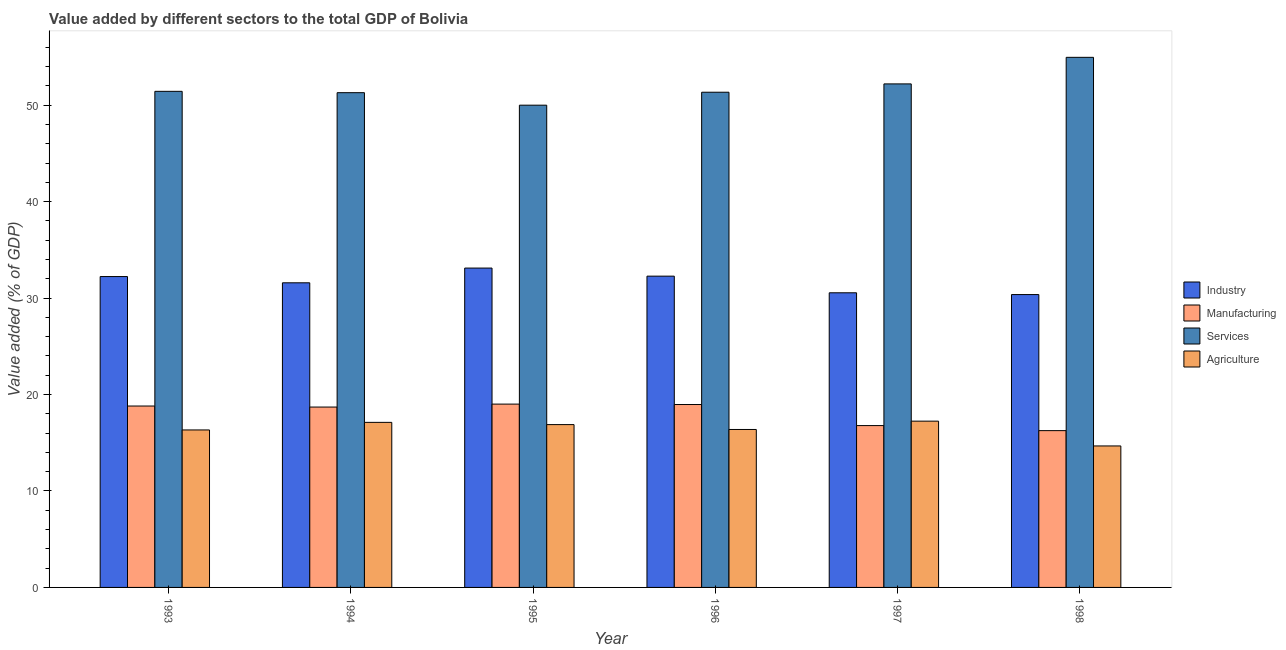How many different coloured bars are there?
Your response must be concise. 4. How many groups of bars are there?
Provide a short and direct response. 6. Are the number of bars per tick equal to the number of legend labels?
Give a very brief answer. Yes. Are the number of bars on each tick of the X-axis equal?
Your answer should be compact. Yes. How many bars are there on the 5th tick from the left?
Offer a terse response. 4. In how many cases, is the number of bars for a given year not equal to the number of legend labels?
Your answer should be compact. 0. What is the value added by services sector in 1998?
Provide a succinct answer. 54.96. Across all years, what is the maximum value added by agricultural sector?
Offer a very short reply. 17.24. Across all years, what is the minimum value added by agricultural sector?
Give a very brief answer. 14.67. In which year was the value added by agricultural sector minimum?
Offer a terse response. 1998. What is the total value added by industrial sector in the graph?
Your answer should be compact. 190.12. What is the difference between the value added by services sector in 1995 and that in 1998?
Your response must be concise. -4.96. What is the difference between the value added by agricultural sector in 1998 and the value added by industrial sector in 1996?
Provide a succinct answer. -1.71. What is the average value added by industrial sector per year?
Give a very brief answer. 31.69. What is the ratio of the value added by services sector in 1994 to that in 1996?
Give a very brief answer. 1. Is the difference between the value added by services sector in 1995 and 1996 greater than the difference between the value added by manufacturing sector in 1995 and 1996?
Make the answer very short. No. What is the difference between the highest and the second highest value added by industrial sector?
Provide a short and direct response. 0.84. What is the difference between the highest and the lowest value added by industrial sector?
Your response must be concise. 2.75. Is it the case that in every year, the sum of the value added by manufacturing sector and value added by services sector is greater than the sum of value added by industrial sector and value added by agricultural sector?
Your response must be concise. No. What does the 2nd bar from the left in 1993 represents?
Ensure brevity in your answer.  Manufacturing. What does the 1st bar from the right in 1998 represents?
Keep it short and to the point. Agriculture. How many bars are there?
Make the answer very short. 24. Are the values on the major ticks of Y-axis written in scientific E-notation?
Your answer should be compact. No. Does the graph contain any zero values?
Make the answer very short. No. Does the graph contain grids?
Your response must be concise. No. How are the legend labels stacked?
Your response must be concise. Vertical. What is the title of the graph?
Keep it short and to the point. Value added by different sectors to the total GDP of Bolivia. What is the label or title of the X-axis?
Make the answer very short. Year. What is the label or title of the Y-axis?
Keep it short and to the point. Value added (% of GDP). What is the Value added (% of GDP) of Industry in 1993?
Ensure brevity in your answer.  32.23. What is the Value added (% of GDP) in Manufacturing in 1993?
Offer a very short reply. 18.81. What is the Value added (% of GDP) of Services in 1993?
Give a very brief answer. 51.44. What is the Value added (% of GDP) of Agriculture in 1993?
Offer a terse response. 16.33. What is the Value added (% of GDP) in Industry in 1994?
Your answer should be compact. 31.59. What is the Value added (% of GDP) of Manufacturing in 1994?
Offer a terse response. 18.7. What is the Value added (% of GDP) of Services in 1994?
Keep it short and to the point. 51.3. What is the Value added (% of GDP) of Agriculture in 1994?
Your answer should be compact. 17.11. What is the Value added (% of GDP) of Industry in 1995?
Provide a short and direct response. 33.11. What is the Value added (% of GDP) in Manufacturing in 1995?
Provide a succinct answer. 19.01. What is the Value added (% of GDP) in Services in 1995?
Your answer should be very brief. 50. What is the Value added (% of GDP) in Agriculture in 1995?
Offer a very short reply. 16.88. What is the Value added (% of GDP) of Industry in 1996?
Give a very brief answer. 32.28. What is the Value added (% of GDP) of Manufacturing in 1996?
Your response must be concise. 18.96. What is the Value added (% of GDP) in Services in 1996?
Provide a succinct answer. 51.35. What is the Value added (% of GDP) in Agriculture in 1996?
Your response must be concise. 16.38. What is the Value added (% of GDP) in Industry in 1997?
Offer a terse response. 30.55. What is the Value added (% of GDP) in Manufacturing in 1997?
Provide a succinct answer. 16.78. What is the Value added (% of GDP) in Services in 1997?
Provide a succinct answer. 52.21. What is the Value added (% of GDP) of Agriculture in 1997?
Your answer should be very brief. 17.24. What is the Value added (% of GDP) in Industry in 1998?
Your response must be concise. 30.37. What is the Value added (% of GDP) in Manufacturing in 1998?
Your answer should be compact. 16.26. What is the Value added (% of GDP) in Services in 1998?
Ensure brevity in your answer.  54.96. What is the Value added (% of GDP) of Agriculture in 1998?
Provide a succinct answer. 14.67. Across all years, what is the maximum Value added (% of GDP) in Industry?
Keep it short and to the point. 33.11. Across all years, what is the maximum Value added (% of GDP) in Manufacturing?
Provide a short and direct response. 19.01. Across all years, what is the maximum Value added (% of GDP) in Services?
Provide a succinct answer. 54.96. Across all years, what is the maximum Value added (% of GDP) in Agriculture?
Keep it short and to the point. 17.24. Across all years, what is the minimum Value added (% of GDP) in Industry?
Ensure brevity in your answer.  30.37. Across all years, what is the minimum Value added (% of GDP) in Manufacturing?
Keep it short and to the point. 16.26. Across all years, what is the minimum Value added (% of GDP) in Services?
Make the answer very short. 50. Across all years, what is the minimum Value added (% of GDP) in Agriculture?
Ensure brevity in your answer.  14.67. What is the total Value added (% of GDP) of Industry in the graph?
Give a very brief answer. 190.12. What is the total Value added (% of GDP) of Manufacturing in the graph?
Your response must be concise. 108.52. What is the total Value added (% of GDP) in Services in the graph?
Provide a succinct answer. 311.26. What is the total Value added (% of GDP) in Agriculture in the graph?
Keep it short and to the point. 98.62. What is the difference between the Value added (% of GDP) of Industry in 1993 and that in 1994?
Ensure brevity in your answer.  0.65. What is the difference between the Value added (% of GDP) of Manufacturing in 1993 and that in 1994?
Provide a succinct answer. 0.11. What is the difference between the Value added (% of GDP) of Services in 1993 and that in 1994?
Provide a short and direct response. 0.14. What is the difference between the Value added (% of GDP) of Agriculture in 1993 and that in 1994?
Your response must be concise. -0.79. What is the difference between the Value added (% of GDP) in Industry in 1993 and that in 1995?
Provide a short and direct response. -0.88. What is the difference between the Value added (% of GDP) in Manufacturing in 1993 and that in 1995?
Keep it short and to the point. -0.2. What is the difference between the Value added (% of GDP) in Services in 1993 and that in 1995?
Offer a terse response. 1.43. What is the difference between the Value added (% of GDP) in Agriculture in 1993 and that in 1995?
Your answer should be compact. -0.55. What is the difference between the Value added (% of GDP) of Industry in 1993 and that in 1996?
Provide a succinct answer. -0.04. What is the difference between the Value added (% of GDP) of Manufacturing in 1993 and that in 1996?
Offer a terse response. -0.16. What is the difference between the Value added (% of GDP) of Services in 1993 and that in 1996?
Your answer should be compact. 0.09. What is the difference between the Value added (% of GDP) in Agriculture in 1993 and that in 1996?
Offer a very short reply. -0.05. What is the difference between the Value added (% of GDP) of Industry in 1993 and that in 1997?
Keep it short and to the point. 1.68. What is the difference between the Value added (% of GDP) of Manufacturing in 1993 and that in 1997?
Your answer should be compact. 2.03. What is the difference between the Value added (% of GDP) in Services in 1993 and that in 1997?
Offer a very short reply. -0.77. What is the difference between the Value added (% of GDP) in Agriculture in 1993 and that in 1997?
Keep it short and to the point. -0.91. What is the difference between the Value added (% of GDP) in Industry in 1993 and that in 1998?
Offer a very short reply. 1.87. What is the difference between the Value added (% of GDP) of Manufacturing in 1993 and that in 1998?
Provide a short and direct response. 2.55. What is the difference between the Value added (% of GDP) in Services in 1993 and that in 1998?
Give a very brief answer. -3.53. What is the difference between the Value added (% of GDP) in Agriculture in 1993 and that in 1998?
Your answer should be compact. 1.66. What is the difference between the Value added (% of GDP) of Industry in 1994 and that in 1995?
Make the answer very short. -1.53. What is the difference between the Value added (% of GDP) in Manufacturing in 1994 and that in 1995?
Give a very brief answer. -0.31. What is the difference between the Value added (% of GDP) of Services in 1994 and that in 1995?
Offer a terse response. 1.3. What is the difference between the Value added (% of GDP) in Agriculture in 1994 and that in 1995?
Offer a terse response. 0.23. What is the difference between the Value added (% of GDP) of Industry in 1994 and that in 1996?
Keep it short and to the point. -0.69. What is the difference between the Value added (% of GDP) in Manufacturing in 1994 and that in 1996?
Offer a very short reply. -0.26. What is the difference between the Value added (% of GDP) of Services in 1994 and that in 1996?
Offer a terse response. -0.05. What is the difference between the Value added (% of GDP) of Agriculture in 1994 and that in 1996?
Give a very brief answer. 0.74. What is the difference between the Value added (% of GDP) of Industry in 1994 and that in 1997?
Offer a terse response. 1.04. What is the difference between the Value added (% of GDP) of Manufacturing in 1994 and that in 1997?
Provide a short and direct response. 1.92. What is the difference between the Value added (% of GDP) of Services in 1994 and that in 1997?
Ensure brevity in your answer.  -0.91. What is the difference between the Value added (% of GDP) in Agriculture in 1994 and that in 1997?
Offer a terse response. -0.13. What is the difference between the Value added (% of GDP) in Industry in 1994 and that in 1998?
Give a very brief answer. 1.22. What is the difference between the Value added (% of GDP) of Manufacturing in 1994 and that in 1998?
Ensure brevity in your answer.  2.44. What is the difference between the Value added (% of GDP) in Services in 1994 and that in 1998?
Give a very brief answer. -3.67. What is the difference between the Value added (% of GDP) of Agriculture in 1994 and that in 1998?
Offer a terse response. 2.44. What is the difference between the Value added (% of GDP) in Industry in 1995 and that in 1996?
Make the answer very short. 0.84. What is the difference between the Value added (% of GDP) of Manufacturing in 1995 and that in 1996?
Give a very brief answer. 0.04. What is the difference between the Value added (% of GDP) of Services in 1995 and that in 1996?
Keep it short and to the point. -1.34. What is the difference between the Value added (% of GDP) of Agriculture in 1995 and that in 1996?
Offer a very short reply. 0.51. What is the difference between the Value added (% of GDP) in Industry in 1995 and that in 1997?
Keep it short and to the point. 2.56. What is the difference between the Value added (% of GDP) in Manufacturing in 1995 and that in 1997?
Keep it short and to the point. 2.23. What is the difference between the Value added (% of GDP) of Services in 1995 and that in 1997?
Your response must be concise. -2.21. What is the difference between the Value added (% of GDP) in Agriculture in 1995 and that in 1997?
Ensure brevity in your answer.  -0.36. What is the difference between the Value added (% of GDP) in Industry in 1995 and that in 1998?
Give a very brief answer. 2.75. What is the difference between the Value added (% of GDP) of Manufacturing in 1995 and that in 1998?
Your answer should be compact. 2.75. What is the difference between the Value added (% of GDP) in Services in 1995 and that in 1998?
Your response must be concise. -4.96. What is the difference between the Value added (% of GDP) in Agriculture in 1995 and that in 1998?
Provide a succinct answer. 2.21. What is the difference between the Value added (% of GDP) in Industry in 1996 and that in 1997?
Provide a short and direct response. 1.73. What is the difference between the Value added (% of GDP) of Manufacturing in 1996 and that in 1997?
Your answer should be very brief. 2.18. What is the difference between the Value added (% of GDP) of Services in 1996 and that in 1997?
Offer a terse response. -0.86. What is the difference between the Value added (% of GDP) of Agriculture in 1996 and that in 1997?
Your response must be concise. -0.86. What is the difference between the Value added (% of GDP) in Industry in 1996 and that in 1998?
Your answer should be very brief. 1.91. What is the difference between the Value added (% of GDP) in Manufacturing in 1996 and that in 1998?
Provide a succinct answer. 2.71. What is the difference between the Value added (% of GDP) of Services in 1996 and that in 1998?
Your answer should be compact. -3.62. What is the difference between the Value added (% of GDP) in Agriculture in 1996 and that in 1998?
Keep it short and to the point. 1.71. What is the difference between the Value added (% of GDP) in Industry in 1997 and that in 1998?
Provide a succinct answer. 0.18. What is the difference between the Value added (% of GDP) in Manufacturing in 1997 and that in 1998?
Offer a terse response. 0.52. What is the difference between the Value added (% of GDP) of Services in 1997 and that in 1998?
Provide a short and direct response. -2.76. What is the difference between the Value added (% of GDP) in Agriculture in 1997 and that in 1998?
Offer a very short reply. 2.57. What is the difference between the Value added (% of GDP) in Industry in 1993 and the Value added (% of GDP) in Manufacturing in 1994?
Give a very brief answer. 13.53. What is the difference between the Value added (% of GDP) of Industry in 1993 and the Value added (% of GDP) of Services in 1994?
Your answer should be compact. -19.07. What is the difference between the Value added (% of GDP) of Industry in 1993 and the Value added (% of GDP) of Agriculture in 1994?
Make the answer very short. 15.12. What is the difference between the Value added (% of GDP) of Manufacturing in 1993 and the Value added (% of GDP) of Services in 1994?
Offer a terse response. -32.49. What is the difference between the Value added (% of GDP) of Manufacturing in 1993 and the Value added (% of GDP) of Agriculture in 1994?
Provide a short and direct response. 1.69. What is the difference between the Value added (% of GDP) of Services in 1993 and the Value added (% of GDP) of Agriculture in 1994?
Give a very brief answer. 34.32. What is the difference between the Value added (% of GDP) of Industry in 1993 and the Value added (% of GDP) of Manufacturing in 1995?
Provide a short and direct response. 13.22. What is the difference between the Value added (% of GDP) of Industry in 1993 and the Value added (% of GDP) of Services in 1995?
Your answer should be compact. -17.77. What is the difference between the Value added (% of GDP) in Industry in 1993 and the Value added (% of GDP) in Agriculture in 1995?
Your answer should be compact. 15.35. What is the difference between the Value added (% of GDP) in Manufacturing in 1993 and the Value added (% of GDP) in Services in 1995?
Your answer should be compact. -31.19. What is the difference between the Value added (% of GDP) of Manufacturing in 1993 and the Value added (% of GDP) of Agriculture in 1995?
Your answer should be very brief. 1.93. What is the difference between the Value added (% of GDP) in Services in 1993 and the Value added (% of GDP) in Agriculture in 1995?
Offer a very short reply. 34.55. What is the difference between the Value added (% of GDP) of Industry in 1993 and the Value added (% of GDP) of Manufacturing in 1996?
Keep it short and to the point. 13.27. What is the difference between the Value added (% of GDP) in Industry in 1993 and the Value added (% of GDP) in Services in 1996?
Your answer should be very brief. -19.11. What is the difference between the Value added (% of GDP) of Industry in 1993 and the Value added (% of GDP) of Agriculture in 1996?
Provide a short and direct response. 15.86. What is the difference between the Value added (% of GDP) of Manufacturing in 1993 and the Value added (% of GDP) of Services in 1996?
Ensure brevity in your answer.  -32.54. What is the difference between the Value added (% of GDP) in Manufacturing in 1993 and the Value added (% of GDP) in Agriculture in 1996?
Your response must be concise. 2.43. What is the difference between the Value added (% of GDP) of Services in 1993 and the Value added (% of GDP) of Agriculture in 1996?
Your response must be concise. 35.06. What is the difference between the Value added (% of GDP) in Industry in 1993 and the Value added (% of GDP) in Manufacturing in 1997?
Your answer should be very brief. 15.45. What is the difference between the Value added (% of GDP) in Industry in 1993 and the Value added (% of GDP) in Services in 1997?
Give a very brief answer. -19.98. What is the difference between the Value added (% of GDP) in Industry in 1993 and the Value added (% of GDP) in Agriculture in 1997?
Provide a succinct answer. 14.99. What is the difference between the Value added (% of GDP) of Manufacturing in 1993 and the Value added (% of GDP) of Services in 1997?
Offer a very short reply. -33.4. What is the difference between the Value added (% of GDP) in Manufacturing in 1993 and the Value added (% of GDP) in Agriculture in 1997?
Ensure brevity in your answer.  1.57. What is the difference between the Value added (% of GDP) of Services in 1993 and the Value added (% of GDP) of Agriculture in 1997?
Provide a succinct answer. 34.2. What is the difference between the Value added (% of GDP) of Industry in 1993 and the Value added (% of GDP) of Manufacturing in 1998?
Provide a short and direct response. 15.98. What is the difference between the Value added (% of GDP) in Industry in 1993 and the Value added (% of GDP) in Services in 1998?
Offer a terse response. -22.73. What is the difference between the Value added (% of GDP) of Industry in 1993 and the Value added (% of GDP) of Agriculture in 1998?
Ensure brevity in your answer.  17.56. What is the difference between the Value added (% of GDP) of Manufacturing in 1993 and the Value added (% of GDP) of Services in 1998?
Offer a very short reply. -36.16. What is the difference between the Value added (% of GDP) in Manufacturing in 1993 and the Value added (% of GDP) in Agriculture in 1998?
Ensure brevity in your answer.  4.14. What is the difference between the Value added (% of GDP) in Services in 1993 and the Value added (% of GDP) in Agriculture in 1998?
Offer a terse response. 36.77. What is the difference between the Value added (% of GDP) in Industry in 1994 and the Value added (% of GDP) in Manufacturing in 1995?
Give a very brief answer. 12.58. What is the difference between the Value added (% of GDP) of Industry in 1994 and the Value added (% of GDP) of Services in 1995?
Give a very brief answer. -18.42. What is the difference between the Value added (% of GDP) of Industry in 1994 and the Value added (% of GDP) of Agriculture in 1995?
Ensure brevity in your answer.  14.7. What is the difference between the Value added (% of GDP) in Manufacturing in 1994 and the Value added (% of GDP) in Services in 1995?
Provide a succinct answer. -31.3. What is the difference between the Value added (% of GDP) in Manufacturing in 1994 and the Value added (% of GDP) in Agriculture in 1995?
Your answer should be compact. 1.82. What is the difference between the Value added (% of GDP) of Services in 1994 and the Value added (% of GDP) of Agriculture in 1995?
Give a very brief answer. 34.42. What is the difference between the Value added (% of GDP) in Industry in 1994 and the Value added (% of GDP) in Manufacturing in 1996?
Give a very brief answer. 12.62. What is the difference between the Value added (% of GDP) in Industry in 1994 and the Value added (% of GDP) in Services in 1996?
Provide a succinct answer. -19.76. What is the difference between the Value added (% of GDP) in Industry in 1994 and the Value added (% of GDP) in Agriculture in 1996?
Your answer should be compact. 15.21. What is the difference between the Value added (% of GDP) in Manufacturing in 1994 and the Value added (% of GDP) in Services in 1996?
Provide a short and direct response. -32.64. What is the difference between the Value added (% of GDP) of Manufacturing in 1994 and the Value added (% of GDP) of Agriculture in 1996?
Your response must be concise. 2.32. What is the difference between the Value added (% of GDP) of Services in 1994 and the Value added (% of GDP) of Agriculture in 1996?
Provide a succinct answer. 34.92. What is the difference between the Value added (% of GDP) of Industry in 1994 and the Value added (% of GDP) of Manufacturing in 1997?
Your answer should be very brief. 14.8. What is the difference between the Value added (% of GDP) of Industry in 1994 and the Value added (% of GDP) of Services in 1997?
Offer a very short reply. -20.62. What is the difference between the Value added (% of GDP) of Industry in 1994 and the Value added (% of GDP) of Agriculture in 1997?
Your answer should be very brief. 14.35. What is the difference between the Value added (% of GDP) of Manufacturing in 1994 and the Value added (% of GDP) of Services in 1997?
Offer a terse response. -33.51. What is the difference between the Value added (% of GDP) in Manufacturing in 1994 and the Value added (% of GDP) in Agriculture in 1997?
Ensure brevity in your answer.  1.46. What is the difference between the Value added (% of GDP) in Services in 1994 and the Value added (% of GDP) in Agriculture in 1997?
Give a very brief answer. 34.06. What is the difference between the Value added (% of GDP) in Industry in 1994 and the Value added (% of GDP) in Manufacturing in 1998?
Keep it short and to the point. 15.33. What is the difference between the Value added (% of GDP) in Industry in 1994 and the Value added (% of GDP) in Services in 1998?
Offer a very short reply. -23.38. What is the difference between the Value added (% of GDP) in Industry in 1994 and the Value added (% of GDP) in Agriculture in 1998?
Your answer should be compact. 16.92. What is the difference between the Value added (% of GDP) in Manufacturing in 1994 and the Value added (% of GDP) in Services in 1998?
Your response must be concise. -36.26. What is the difference between the Value added (% of GDP) in Manufacturing in 1994 and the Value added (% of GDP) in Agriculture in 1998?
Offer a terse response. 4.03. What is the difference between the Value added (% of GDP) in Services in 1994 and the Value added (% of GDP) in Agriculture in 1998?
Your response must be concise. 36.63. What is the difference between the Value added (% of GDP) of Industry in 1995 and the Value added (% of GDP) of Manufacturing in 1996?
Your answer should be very brief. 14.15. What is the difference between the Value added (% of GDP) in Industry in 1995 and the Value added (% of GDP) in Services in 1996?
Provide a short and direct response. -18.23. What is the difference between the Value added (% of GDP) in Industry in 1995 and the Value added (% of GDP) in Agriculture in 1996?
Your answer should be compact. 16.74. What is the difference between the Value added (% of GDP) of Manufacturing in 1995 and the Value added (% of GDP) of Services in 1996?
Give a very brief answer. -32.34. What is the difference between the Value added (% of GDP) of Manufacturing in 1995 and the Value added (% of GDP) of Agriculture in 1996?
Your answer should be compact. 2.63. What is the difference between the Value added (% of GDP) in Services in 1995 and the Value added (% of GDP) in Agriculture in 1996?
Ensure brevity in your answer.  33.63. What is the difference between the Value added (% of GDP) in Industry in 1995 and the Value added (% of GDP) in Manufacturing in 1997?
Offer a terse response. 16.33. What is the difference between the Value added (% of GDP) in Industry in 1995 and the Value added (% of GDP) in Services in 1997?
Your answer should be very brief. -19.1. What is the difference between the Value added (% of GDP) of Industry in 1995 and the Value added (% of GDP) of Agriculture in 1997?
Your response must be concise. 15.87. What is the difference between the Value added (% of GDP) in Manufacturing in 1995 and the Value added (% of GDP) in Services in 1997?
Keep it short and to the point. -33.2. What is the difference between the Value added (% of GDP) in Manufacturing in 1995 and the Value added (% of GDP) in Agriculture in 1997?
Ensure brevity in your answer.  1.77. What is the difference between the Value added (% of GDP) in Services in 1995 and the Value added (% of GDP) in Agriculture in 1997?
Your answer should be very brief. 32.76. What is the difference between the Value added (% of GDP) in Industry in 1995 and the Value added (% of GDP) in Manufacturing in 1998?
Provide a short and direct response. 16.86. What is the difference between the Value added (% of GDP) of Industry in 1995 and the Value added (% of GDP) of Services in 1998?
Offer a terse response. -21.85. What is the difference between the Value added (% of GDP) of Industry in 1995 and the Value added (% of GDP) of Agriculture in 1998?
Your answer should be compact. 18.44. What is the difference between the Value added (% of GDP) of Manufacturing in 1995 and the Value added (% of GDP) of Services in 1998?
Provide a short and direct response. -35.96. What is the difference between the Value added (% of GDP) of Manufacturing in 1995 and the Value added (% of GDP) of Agriculture in 1998?
Give a very brief answer. 4.34. What is the difference between the Value added (% of GDP) in Services in 1995 and the Value added (% of GDP) in Agriculture in 1998?
Your answer should be compact. 35.33. What is the difference between the Value added (% of GDP) of Industry in 1996 and the Value added (% of GDP) of Manufacturing in 1997?
Provide a short and direct response. 15.5. What is the difference between the Value added (% of GDP) of Industry in 1996 and the Value added (% of GDP) of Services in 1997?
Give a very brief answer. -19.93. What is the difference between the Value added (% of GDP) of Industry in 1996 and the Value added (% of GDP) of Agriculture in 1997?
Ensure brevity in your answer.  15.04. What is the difference between the Value added (% of GDP) of Manufacturing in 1996 and the Value added (% of GDP) of Services in 1997?
Give a very brief answer. -33.24. What is the difference between the Value added (% of GDP) of Manufacturing in 1996 and the Value added (% of GDP) of Agriculture in 1997?
Keep it short and to the point. 1.72. What is the difference between the Value added (% of GDP) of Services in 1996 and the Value added (% of GDP) of Agriculture in 1997?
Give a very brief answer. 34.11. What is the difference between the Value added (% of GDP) of Industry in 1996 and the Value added (% of GDP) of Manufacturing in 1998?
Give a very brief answer. 16.02. What is the difference between the Value added (% of GDP) in Industry in 1996 and the Value added (% of GDP) in Services in 1998?
Your answer should be compact. -22.69. What is the difference between the Value added (% of GDP) of Industry in 1996 and the Value added (% of GDP) of Agriculture in 1998?
Your answer should be compact. 17.61. What is the difference between the Value added (% of GDP) of Manufacturing in 1996 and the Value added (% of GDP) of Services in 1998?
Keep it short and to the point. -36. What is the difference between the Value added (% of GDP) of Manufacturing in 1996 and the Value added (% of GDP) of Agriculture in 1998?
Your answer should be very brief. 4.29. What is the difference between the Value added (% of GDP) of Services in 1996 and the Value added (% of GDP) of Agriculture in 1998?
Offer a very short reply. 36.68. What is the difference between the Value added (% of GDP) in Industry in 1997 and the Value added (% of GDP) in Manufacturing in 1998?
Your response must be concise. 14.29. What is the difference between the Value added (% of GDP) of Industry in 1997 and the Value added (% of GDP) of Services in 1998?
Provide a short and direct response. -24.41. What is the difference between the Value added (% of GDP) of Industry in 1997 and the Value added (% of GDP) of Agriculture in 1998?
Provide a succinct answer. 15.88. What is the difference between the Value added (% of GDP) in Manufacturing in 1997 and the Value added (% of GDP) in Services in 1998?
Give a very brief answer. -38.18. What is the difference between the Value added (% of GDP) of Manufacturing in 1997 and the Value added (% of GDP) of Agriculture in 1998?
Offer a very short reply. 2.11. What is the difference between the Value added (% of GDP) of Services in 1997 and the Value added (% of GDP) of Agriculture in 1998?
Ensure brevity in your answer.  37.54. What is the average Value added (% of GDP) in Industry per year?
Offer a terse response. 31.69. What is the average Value added (% of GDP) in Manufacturing per year?
Provide a short and direct response. 18.09. What is the average Value added (% of GDP) in Services per year?
Your response must be concise. 51.88. What is the average Value added (% of GDP) of Agriculture per year?
Make the answer very short. 16.44. In the year 1993, what is the difference between the Value added (% of GDP) in Industry and Value added (% of GDP) in Manufacturing?
Your answer should be very brief. 13.42. In the year 1993, what is the difference between the Value added (% of GDP) in Industry and Value added (% of GDP) in Services?
Give a very brief answer. -19.2. In the year 1993, what is the difference between the Value added (% of GDP) in Industry and Value added (% of GDP) in Agriculture?
Give a very brief answer. 15.9. In the year 1993, what is the difference between the Value added (% of GDP) in Manufacturing and Value added (% of GDP) in Services?
Your response must be concise. -32.63. In the year 1993, what is the difference between the Value added (% of GDP) in Manufacturing and Value added (% of GDP) in Agriculture?
Keep it short and to the point. 2.48. In the year 1993, what is the difference between the Value added (% of GDP) of Services and Value added (% of GDP) of Agriculture?
Provide a succinct answer. 35.11. In the year 1994, what is the difference between the Value added (% of GDP) of Industry and Value added (% of GDP) of Manufacturing?
Keep it short and to the point. 12.88. In the year 1994, what is the difference between the Value added (% of GDP) of Industry and Value added (% of GDP) of Services?
Provide a succinct answer. -19.71. In the year 1994, what is the difference between the Value added (% of GDP) in Industry and Value added (% of GDP) in Agriculture?
Provide a succinct answer. 14.47. In the year 1994, what is the difference between the Value added (% of GDP) of Manufacturing and Value added (% of GDP) of Services?
Provide a succinct answer. -32.6. In the year 1994, what is the difference between the Value added (% of GDP) in Manufacturing and Value added (% of GDP) in Agriculture?
Keep it short and to the point. 1.59. In the year 1994, what is the difference between the Value added (% of GDP) in Services and Value added (% of GDP) in Agriculture?
Your response must be concise. 34.18. In the year 1995, what is the difference between the Value added (% of GDP) of Industry and Value added (% of GDP) of Manufacturing?
Offer a very short reply. 14.1. In the year 1995, what is the difference between the Value added (% of GDP) of Industry and Value added (% of GDP) of Services?
Keep it short and to the point. -16.89. In the year 1995, what is the difference between the Value added (% of GDP) of Industry and Value added (% of GDP) of Agriculture?
Make the answer very short. 16.23. In the year 1995, what is the difference between the Value added (% of GDP) in Manufacturing and Value added (% of GDP) in Services?
Offer a terse response. -30.99. In the year 1995, what is the difference between the Value added (% of GDP) of Manufacturing and Value added (% of GDP) of Agriculture?
Offer a terse response. 2.12. In the year 1995, what is the difference between the Value added (% of GDP) of Services and Value added (% of GDP) of Agriculture?
Offer a terse response. 33.12. In the year 1996, what is the difference between the Value added (% of GDP) in Industry and Value added (% of GDP) in Manufacturing?
Offer a terse response. 13.31. In the year 1996, what is the difference between the Value added (% of GDP) in Industry and Value added (% of GDP) in Services?
Provide a short and direct response. -19.07. In the year 1996, what is the difference between the Value added (% of GDP) of Industry and Value added (% of GDP) of Agriculture?
Provide a succinct answer. 15.9. In the year 1996, what is the difference between the Value added (% of GDP) of Manufacturing and Value added (% of GDP) of Services?
Offer a very short reply. -32.38. In the year 1996, what is the difference between the Value added (% of GDP) of Manufacturing and Value added (% of GDP) of Agriculture?
Ensure brevity in your answer.  2.59. In the year 1996, what is the difference between the Value added (% of GDP) in Services and Value added (% of GDP) in Agriculture?
Provide a short and direct response. 34.97. In the year 1997, what is the difference between the Value added (% of GDP) in Industry and Value added (% of GDP) in Manufacturing?
Ensure brevity in your answer.  13.77. In the year 1997, what is the difference between the Value added (% of GDP) in Industry and Value added (% of GDP) in Services?
Provide a succinct answer. -21.66. In the year 1997, what is the difference between the Value added (% of GDP) of Industry and Value added (% of GDP) of Agriculture?
Your answer should be compact. 13.31. In the year 1997, what is the difference between the Value added (% of GDP) of Manufacturing and Value added (% of GDP) of Services?
Give a very brief answer. -35.43. In the year 1997, what is the difference between the Value added (% of GDP) of Manufacturing and Value added (% of GDP) of Agriculture?
Offer a very short reply. -0.46. In the year 1997, what is the difference between the Value added (% of GDP) of Services and Value added (% of GDP) of Agriculture?
Give a very brief answer. 34.97. In the year 1998, what is the difference between the Value added (% of GDP) in Industry and Value added (% of GDP) in Manufacturing?
Keep it short and to the point. 14.11. In the year 1998, what is the difference between the Value added (% of GDP) of Industry and Value added (% of GDP) of Services?
Provide a short and direct response. -24.6. In the year 1998, what is the difference between the Value added (% of GDP) in Industry and Value added (% of GDP) in Agriculture?
Provide a succinct answer. 15.7. In the year 1998, what is the difference between the Value added (% of GDP) in Manufacturing and Value added (% of GDP) in Services?
Offer a terse response. -38.71. In the year 1998, what is the difference between the Value added (% of GDP) of Manufacturing and Value added (% of GDP) of Agriculture?
Offer a terse response. 1.59. In the year 1998, what is the difference between the Value added (% of GDP) of Services and Value added (% of GDP) of Agriculture?
Your response must be concise. 40.29. What is the ratio of the Value added (% of GDP) of Industry in 1993 to that in 1994?
Your response must be concise. 1.02. What is the ratio of the Value added (% of GDP) in Manufacturing in 1993 to that in 1994?
Keep it short and to the point. 1.01. What is the ratio of the Value added (% of GDP) in Agriculture in 1993 to that in 1994?
Offer a very short reply. 0.95. What is the ratio of the Value added (% of GDP) of Industry in 1993 to that in 1995?
Your response must be concise. 0.97. What is the ratio of the Value added (% of GDP) in Manufacturing in 1993 to that in 1995?
Offer a very short reply. 0.99. What is the ratio of the Value added (% of GDP) of Services in 1993 to that in 1995?
Keep it short and to the point. 1.03. What is the ratio of the Value added (% of GDP) of Agriculture in 1993 to that in 1995?
Your answer should be compact. 0.97. What is the ratio of the Value added (% of GDP) of Industry in 1993 to that in 1996?
Give a very brief answer. 1. What is the ratio of the Value added (% of GDP) of Agriculture in 1993 to that in 1996?
Give a very brief answer. 1. What is the ratio of the Value added (% of GDP) in Industry in 1993 to that in 1997?
Provide a short and direct response. 1.06. What is the ratio of the Value added (% of GDP) of Manufacturing in 1993 to that in 1997?
Give a very brief answer. 1.12. What is the ratio of the Value added (% of GDP) of Services in 1993 to that in 1997?
Your answer should be very brief. 0.99. What is the ratio of the Value added (% of GDP) in Agriculture in 1993 to that in 1997?
Give a very brief answer. 0.95. What is the ratio of the Value added (% of GDP) of Industry in 1993 to that in 1998?
Make the answer very short. 1.06. What is the ratio of the Value added (% of GDP) in Manufacturing in 1993 to that in 1998?
Your answer should be compact. 1.16. What is the ratio of the Value added (% of GDP) in Services in 1993 to that in 1998?
Provide a short and direct response. 0.94. What is the ratio of the Value added (% of GDP) of Agriculture in 1993 to that in 1998?
Your answer should be very brief. 1.11. What is the ratio of the Value added (% of GDP) of Industry in 1994 to that in 1995?
Your response must be concise. 0.95. What is the ratio of the Value added (% of GDP) in Manufacturing in 1994 to that in 1995?
Offer a very short reply. 0.98. What is the ratio of the Value added (% of GDP) in Services in 1994 to that in 1995?
Make the answer very short. 1.03. What is the ratio of the Value added (% of GDP) in Agriculture in 1994 to that in 1995?
Give a very brief answer. 1.01. What is the ratio of the Value added (% of GDP) in Industry in 1994 to that in 1996?
Offer a terse response. 0.98. What is the ratio of the Value added (% of GDP) in Manufacturing in 1994 to that in 1996?
Provide a short and direct response. 0.99. What is the ratio of the Value added (% of GDP) in Services in 1994 to that in 1996?
Give a very brief answer. 1. What is the ratio of the Value added (% of GDP) of Agriculture in 1994 to that in 1996?
Your response must be concise. 1.04. What is the ratio of the Value added (% of GDP) of Industry in 1994 to that in 1997?
Ensure brevity in your answer.  1.03. What is the ratio of the Value added (% of GDP) of Manufacturing in 1994 to that in 1997?
Provide a succinct answer. 1.11. What is the ratio of the Value added (% of GDP) in Services in 1994 to that in 1997?
Provide a succinct answer. 0.98. What is the ratio of the Value added (% of GDP) of Industry in 1994 to that in 1998?
Give a very brief answer. 1.04. What is the ratio of the Value added (% of GDP) of Manufacturing in 1994 to that in 1998?
Provide a short and direct response. 1.15. What is the ratio of the Value added (% of GDP) in Services in 1994 to that in 1998?
Provide a succinct answer. 0.93. What is the ratio of the Value added (% of GDP) in Industry in 1995 to that in 1996?
Your answer should be very brief. 1.03. What is the ratio of the Value added (% of GDP) in Services in 1995 to that in 1996?
Your answer should be compact. 0.97. What is the ratio of the Value added (% of GDP) of Agriculture in 1995 to that in 1996?
Provide a short and direct response. 1.03. What is the ratio of the Value added (% of GDP) of Industry in 1995 to that in 1997?
Give a very brief answer. 1.08. What is the ratio of the Value added (% of GDP) in Manufacturing in 1995 to that in 1997?
Keep it short and to the point. 1.13. What is the ratio of the Value added (% of GDP) of Services in 1995 to that in 1997?
Give a very brief answer. 0.96. What is the ratio of the Value added (% of GDP) in Agriculture in 1995 to that in 1997?
Offer a very short reply. 0.98. What is the ratio of the Value added (% of GDP) of Industry in 1995 to that in 1998?
Provide a succinct answer. 1.09. What is the ratio of the Value added (% of GDP) in Manufacturing in 1995 to that in 1998?
Your response must be concise. 1.17. What is the ratio of the Value added (% of GDP) of Services in 1995 to that in 1998?
Your answer should be very brief. 0.91. What is the ratio of the Value added (% of GDP) in Agriculture in 1995 to that in 1998?
Your answer should be very brief. 1.15. What is the ratio of the Value added (% of GDP) of Industry in 1996 to that in 1997?
Offer a very short reply. 1.06. What is the ratio of the Value added (% of GDP) in Manufacturing in 1996 to that in 1997?
Offer a terse response. 1.13. What is the ratio of the Value added (% of GDP) in Services in 1996 to that in 1997?
Provide a short and direct response. 0.98. What is the ratio of the Value added (% of GDP) of Agriculture in 1996 to that in 1997?
Make the answer very short. 0.95. What is the ratio of the Value added (% of GDP) in Industry in 1996 to that in 1998?
Your response must be concise. 1.06. What is the ratio of the Value added (% of GDP) in Manufacturing in 1996 to that in 1998?
Ensure brevity in your answer.  1.17. What is the ratio of the Value added (% of GDP) in Services in 1996 to that in 1998?
Provide a succinct answer. 0.93. What is the ratio of the Value added (% of GDP) of Agriculture in 1996 to that in 1998?
Make the answer very short. 1.12. What is the ratio of the Value added (% of GDP) of Manufacturing in 1997 to that in 1998?
Keep it short and to the point. 1.03. What is the ratio of the Value added (% of GDP) in Services in 1997 to that in 1998?
Offer a very short reply. 0.95. What is the ratio of the Value added (% of GDP) of Agriculture in 1997 to that in 1998?
Your answer should be compact. 1.18. What is the difference between the highest and the second highest Value added (% of GDP) of Industry?
Keep it short and to the point. 0.84. What is the difference between the highest and the second highest Value added (% of GDP) of Manufacturing?
Provide a succinct answer. 0.04. What is the difference between the highest and the second highest Value added (% of GDP) in Services?
Offer a terse response. 2.76. What is the difference between the highest and the second highest Value added (% of GDP) in Agriculture?
Provide a short and direct response. 0.13. What is the difference between the highest and the lowest Value added (% of GDP) of Industry?
Offer a terse response. 2.75. What is the difference between the highest and the lowest Value added (% of GDP) in Manufacturing?
Provide a short and direct response. 2.75. What is the difference between the highest and the lowest Value added (% of GDP) of Services?
Provide a succinct answer. 4.96. What is the difference between the highest and the lowest Value added (% of GDP) in Agriculture?
Provide a short and direct response. 2.57. 